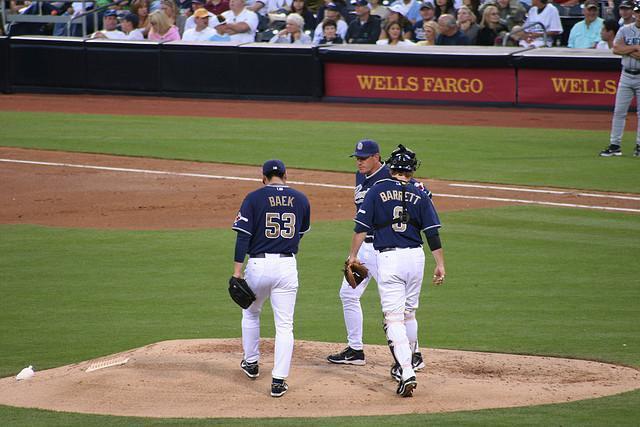How many people are in the photo?
Give a very brief answer. 5. 